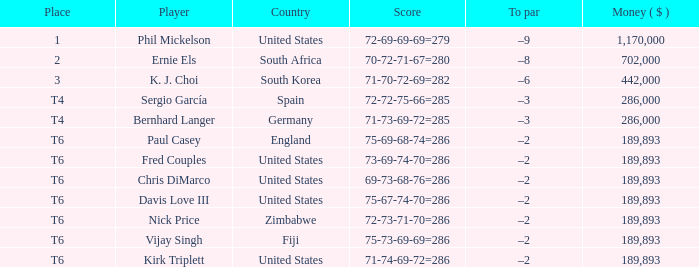What is the Money ($) when the Place is t6, and Player is chris dimarco? 189893.0. 